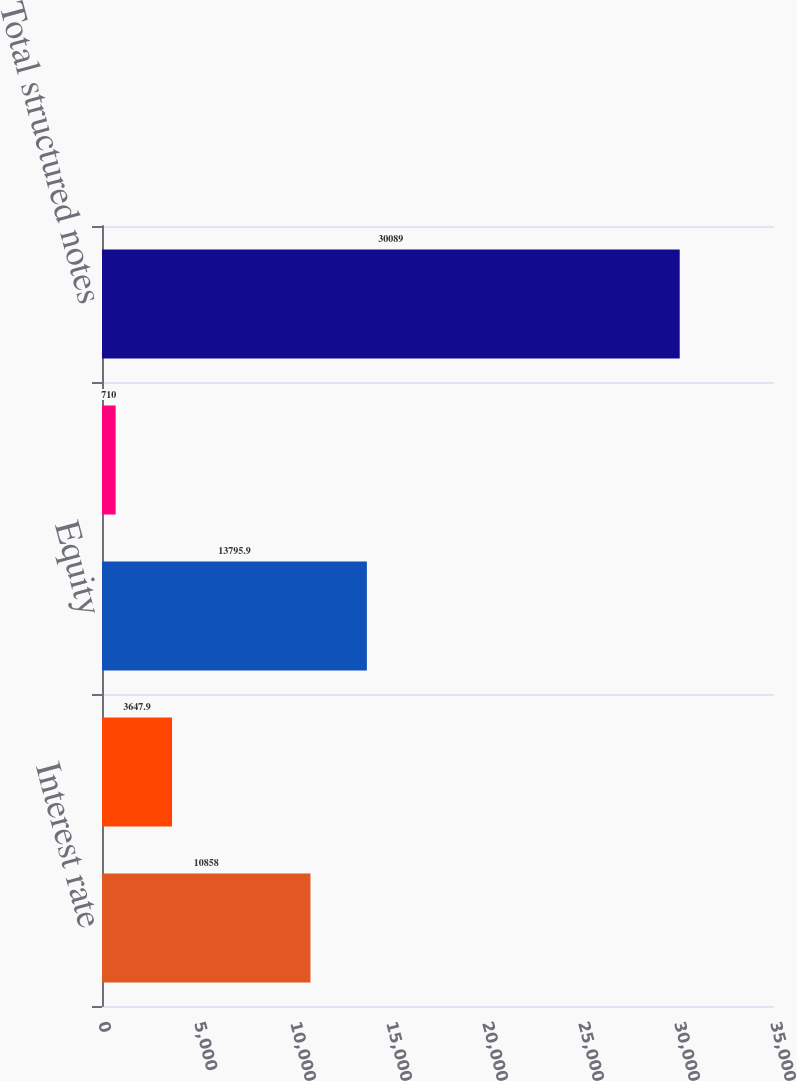<chart> <loc_0><loc_0><loc_500><loc_500><bar_chart><fcel>Interest rate<fcel>Foreign exchange<fcel>Equity<fcel>Commodity<fcel>Total structured notes<nl><fcel>10858<fcel>3647.9<fcel>13795.9<fcel>710<fcel>30089<nl></chart> 